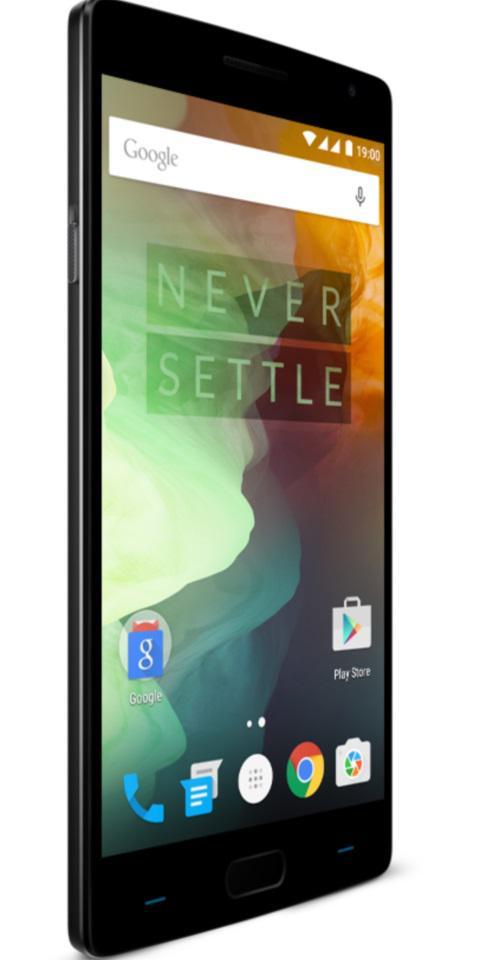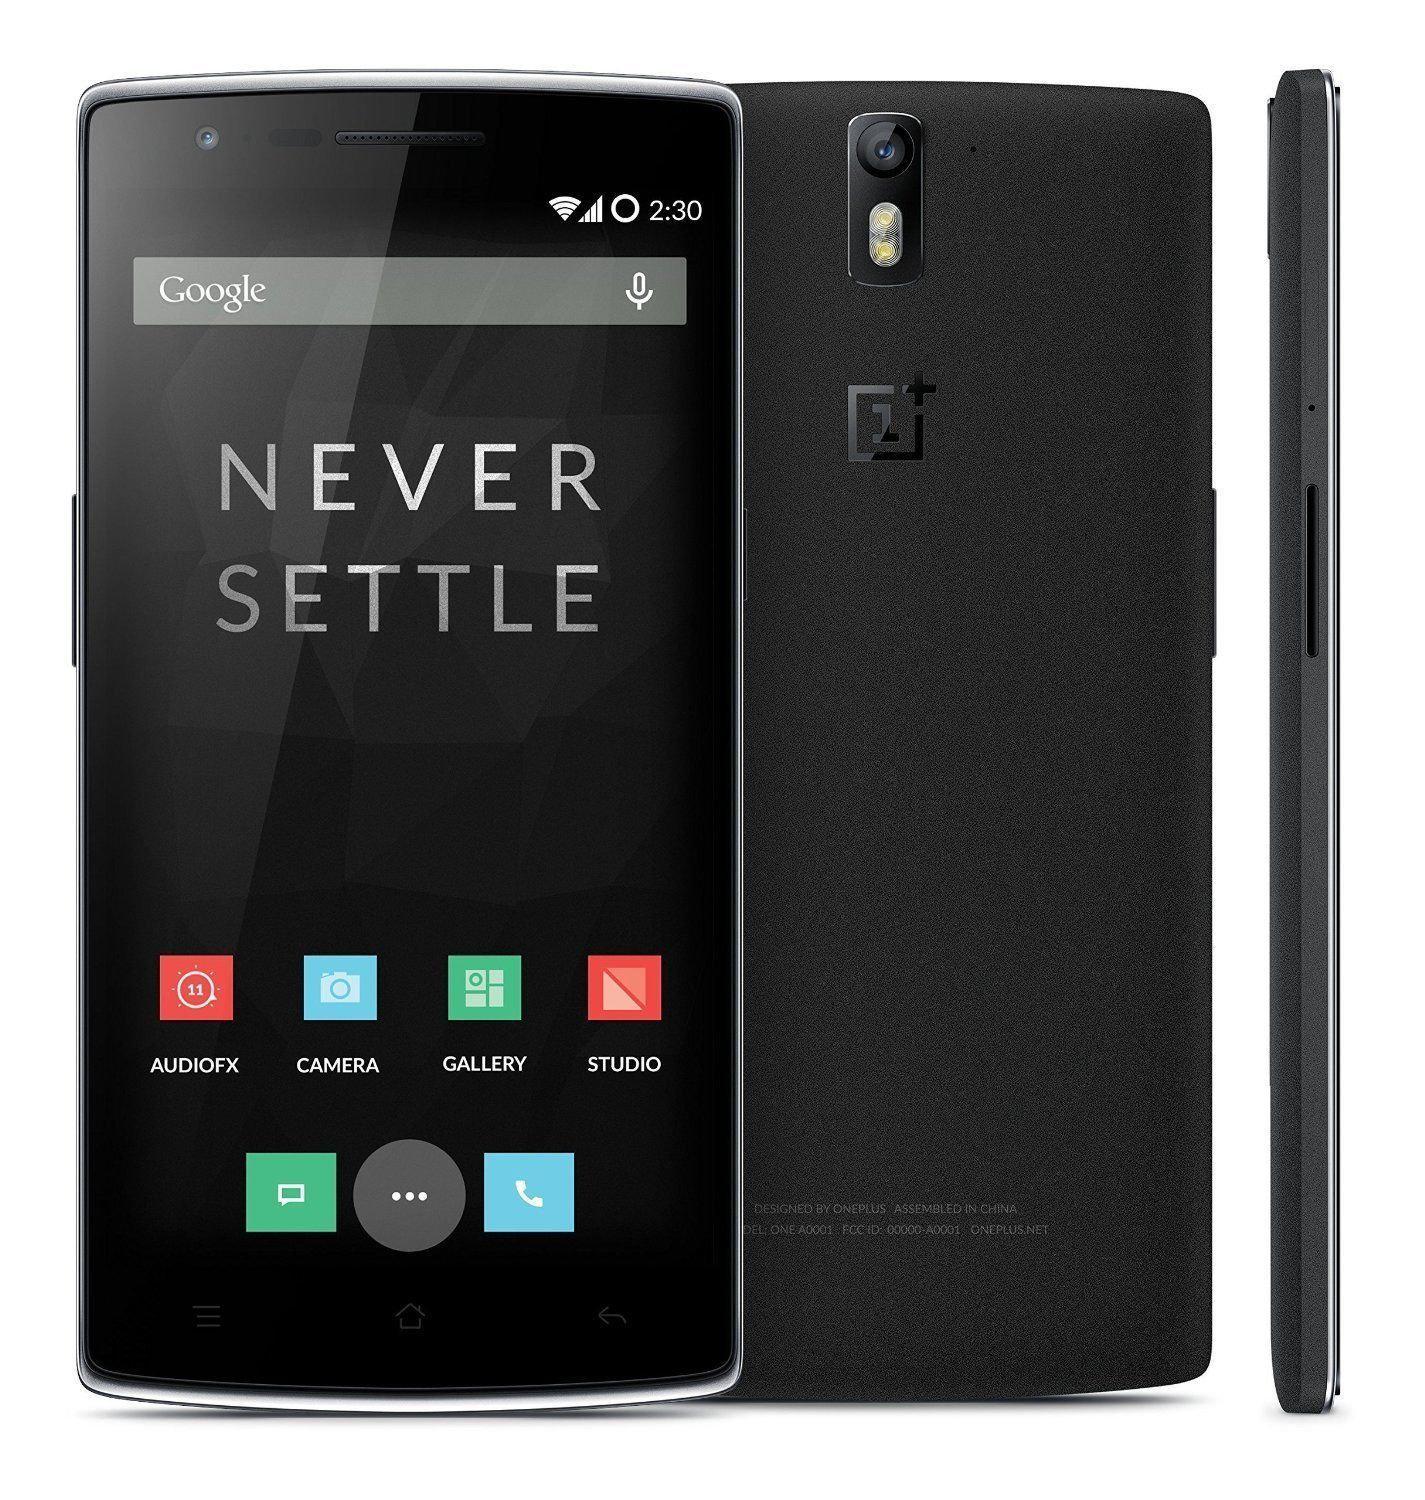The first image is the image on the left, the second image is the image on the right. Assess this claim about the two images: "Each image shows a device viewed head-on, and at least one of the images shows an overlapping device.". Correct or not? Answer yes or no. No. The first image is the image on the left, the second image is the image on the right. Evaluate the accuracy of this statement regarding the images: "The phone screen is completely visible in each image.". Is it true? Answer yes or no. Yes. 